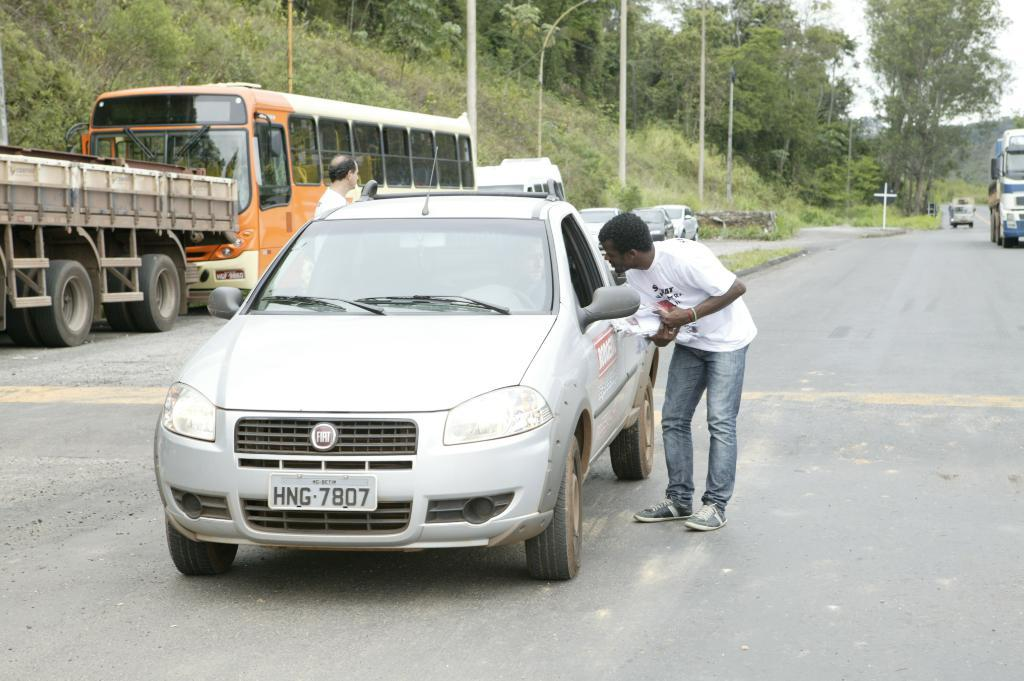What is the man in the image doing? The man is standing next to a car in the image. What can be seen in the background of the image? There are multiple vehicles, trees, and street poles in the background of the image. Are there any other people visible in the image? Yes, there is at least one other person standing in the background of the image. What type of wire is being used to hold up the balloons in the image? There are no balloons present in the image, so there is no wire being used to hold them up. 